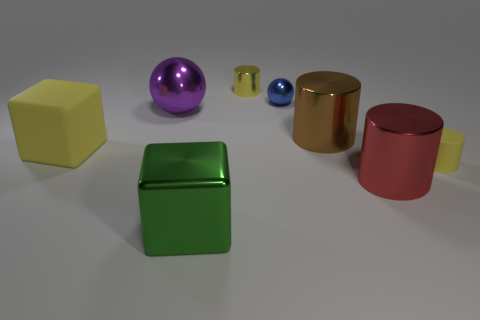What colors are the cylinders in the image? The cylinders in the image are gold, blue, and red. 